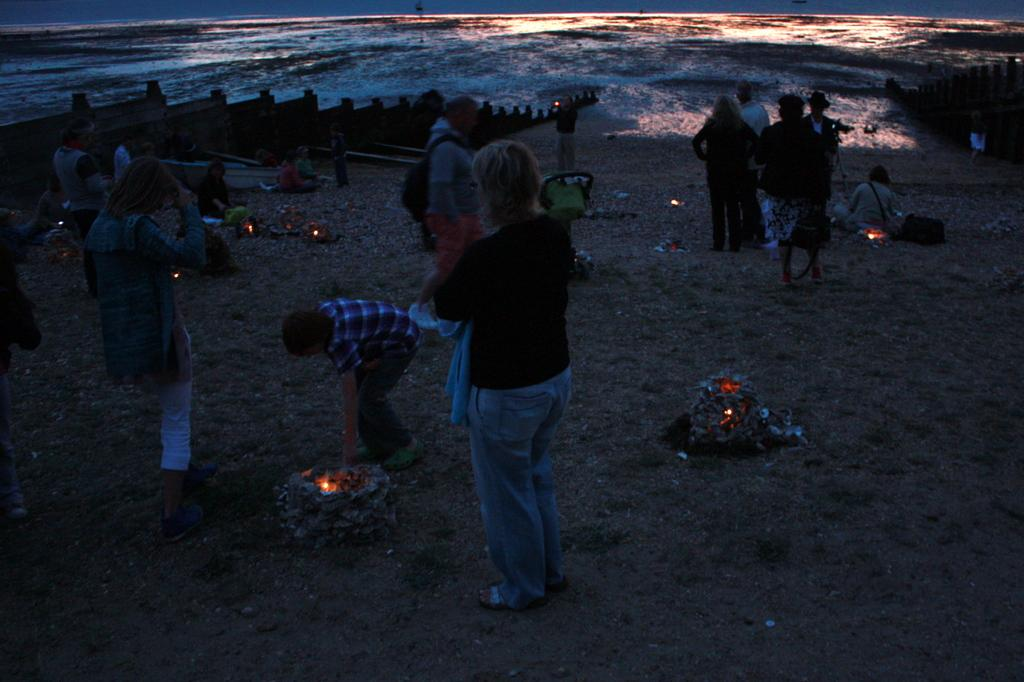What is the main subject of the image? The main subject of the image is a group of people. What is happening at the bottom of the image? There appears to be fire at the bottom of the image. What can be seen at the top of the image? There is water visible at the top of the image. What type of lipstick is the person in the image wearing? There is no person wearing lipstick in the image; it features a group of people and fire at the bottom. 